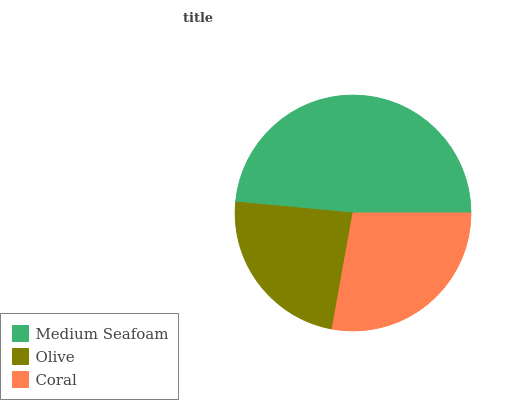Is Olive the minimum?
Answer yes or no. Yes. Is Medium Seafoam the maximum?
Answer yes or no. Yes. Is Coral the minimum?
Answer yes or no. No. Is Coral the maximum?
Answer yes or no. No. Is Coral greater than Olive?
Answer yes or no. Yes. Is Olive less than Coral?
Answer yes or no. Yes. Is Olive greater than Coral?
Answer yes or no. No. Is Coral less than Olive?
Answer yes or no. No. Is Coral the high median?
Answer yes or no. Yes. Is Coral the low median?
Answer yes or no. Yes. Is Olive the high median?
Answer yes or no. No. Is Medium Seafoam the low median?
Answer yes or no. No. 